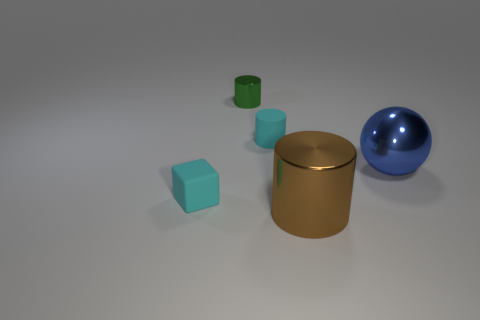Subtract all tiny green metal cylinders. How many cylinders are left? 2 Subtract all green cylinders. How many cylinders are left? 2 Add 4 blue metallic objects. How many objects exist? 9 Subtract 1 cyan cylinders. How many objects are left? 4 Subtract all blocks. How many objects are left? 4 Subtract 2 cylinders. How many cylinders are left? 1 Subtract all gray balls. Subtract all gray cylinders. How many balls are left? 1 Subtract all brown cubes. How many red balls are left? 0 Subtract all tiny rubber cubes. Subtract all blue spheres. How many objects are left? 3 Add 1 blue balls. How many blue balls are left? 2 